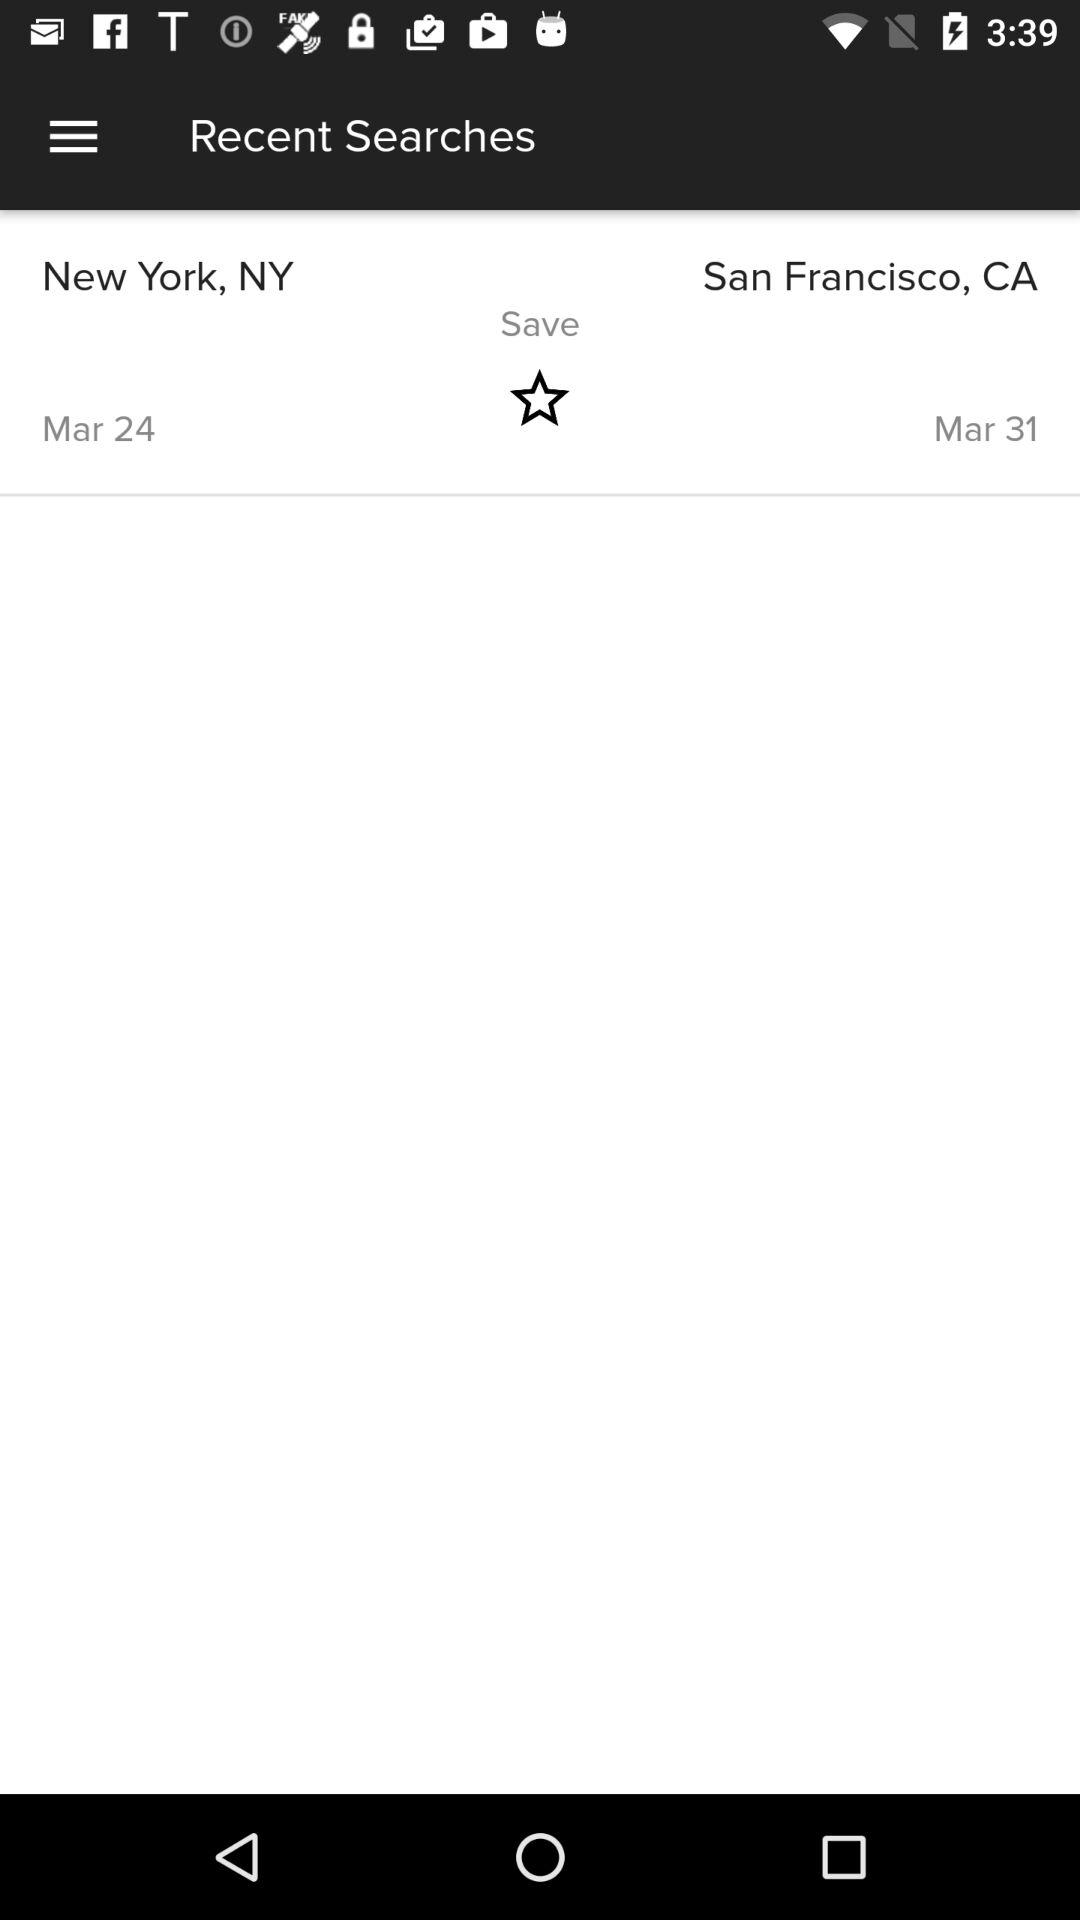What is the start location? The start location is New York, NY. 